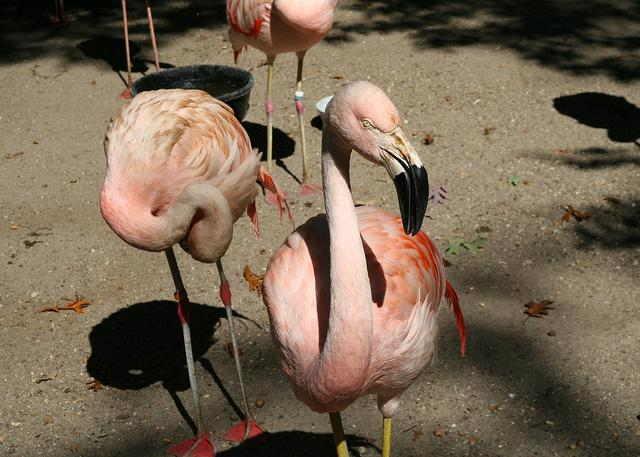What aquatic order are these birds from? flamingo 